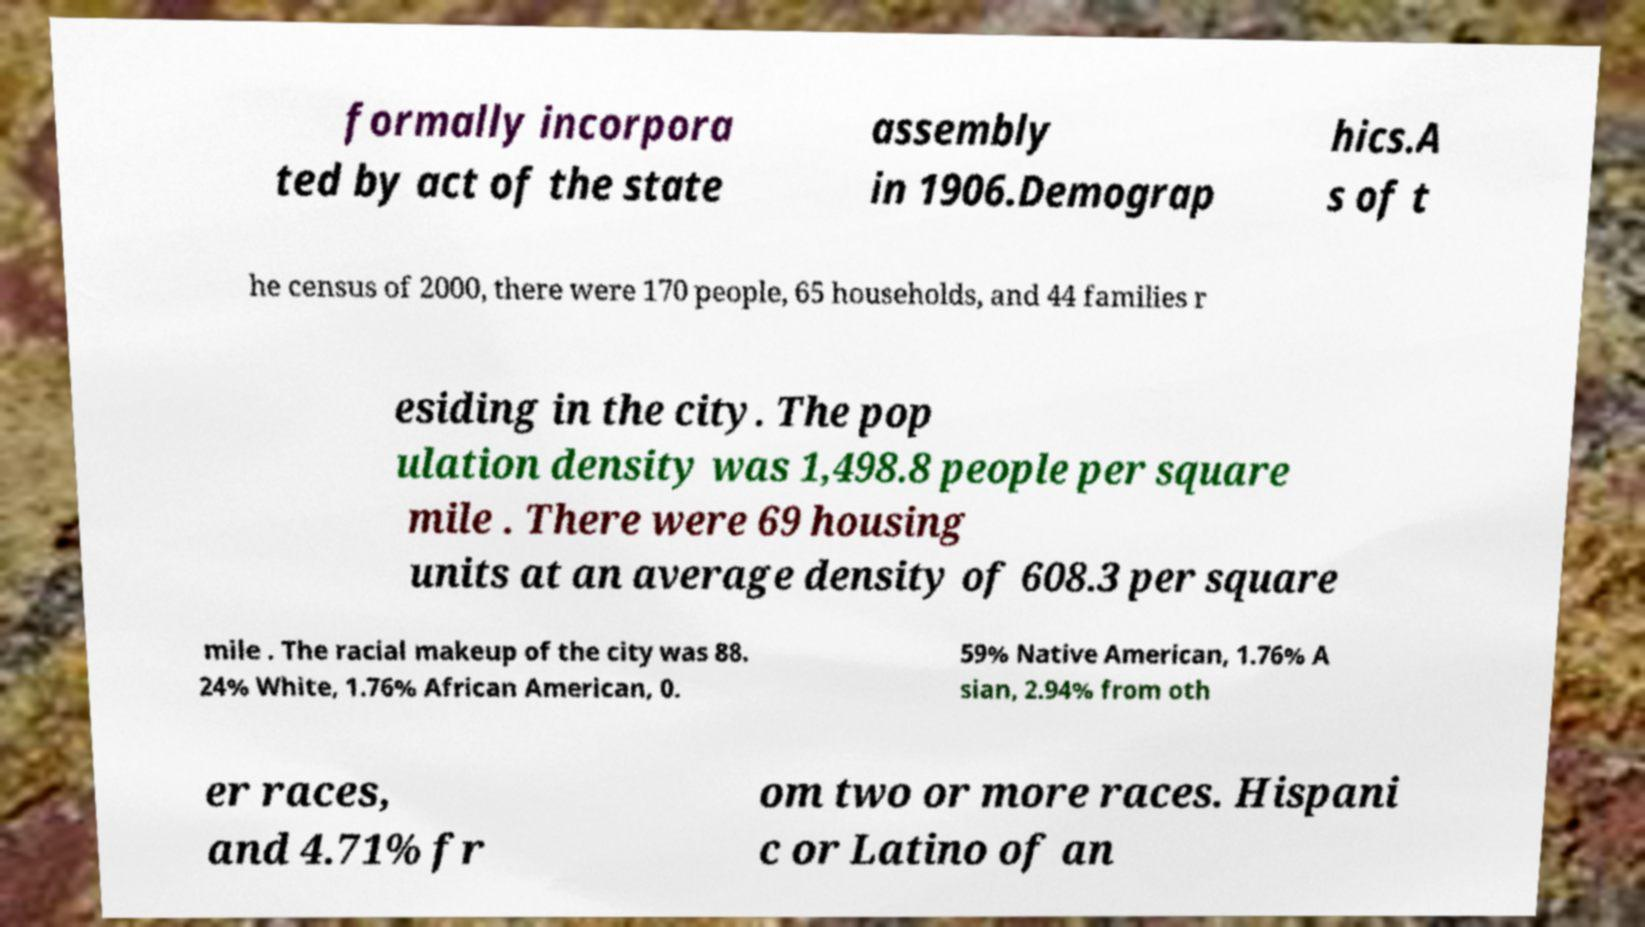Please identify and transcribe the text found in this image. formally incorpora ted by act of the state assembly in 1906.Demograp hics.A s of t he census of 2000, there were 170 people, 65 households, and 44 families r esiding in the city. The pop ulation density was 1,498.8 people per square mile . There were 69 housing units at an average density of 608.3 per square mile . The racial makeup of the city was 88. 24% White, 1.76% African American, 0. 59% Native American, 1.76% A sian, 2.94% from oth er races, and 4.71% fr om two or more races. Hispani c or Latino of an 